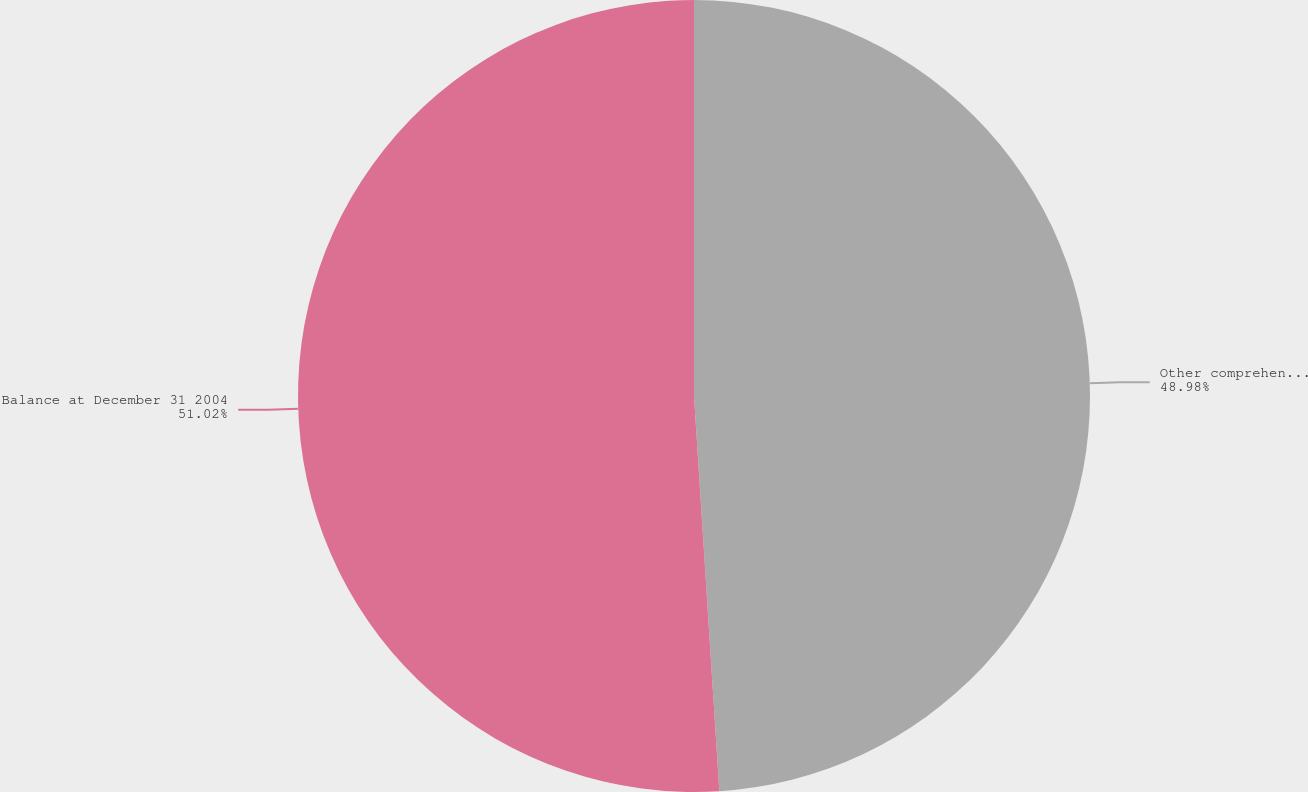<chart> <loc_0><loc_0><loc_500><loc_500><pie_chart><fcel>Other comprehensive income<fcel>Balance at December 31 2004<nl><fcel>48.98%<fcel>51.02%<nl></chart> 